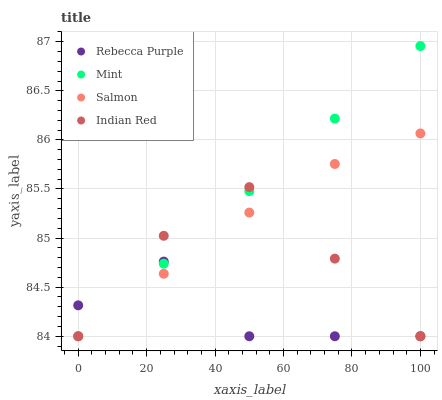Does Rebecca Purple have the minimum area under the curve?
Answer yes or no. Yes. Does Mint have the maximum area under the curve?
Answer yes or no. Yes. Does Mint have the minimum area under the curve?
Answer yes or no. No. Does Rebecca Purple have the maximum area under the curve?
Answer yes or no. No. Is Mint the smoothest?
Answer yes or no. Yes. Is Rebecca Purple the roughest?
Answer yes or no. Yes. Is Rebecca Purple the smoothest?
Answer yes or no. No. Is Mint the roughest?
Answer yes or no. No. Does Salmon have the lowest value?
Answer yes or no. Yes. Does Mint have the highest value?
Answer yes or no. Yes. Does Rebecca Purple have the highest value?
Answer yes or no. No. Does Mint intersect Indian Red?
Answer yes or no. Yes. Is Mint less than Indian Red?
Answer yes or no. No. Is Mint greater than Indian Red?
Answer yes or no. No. 